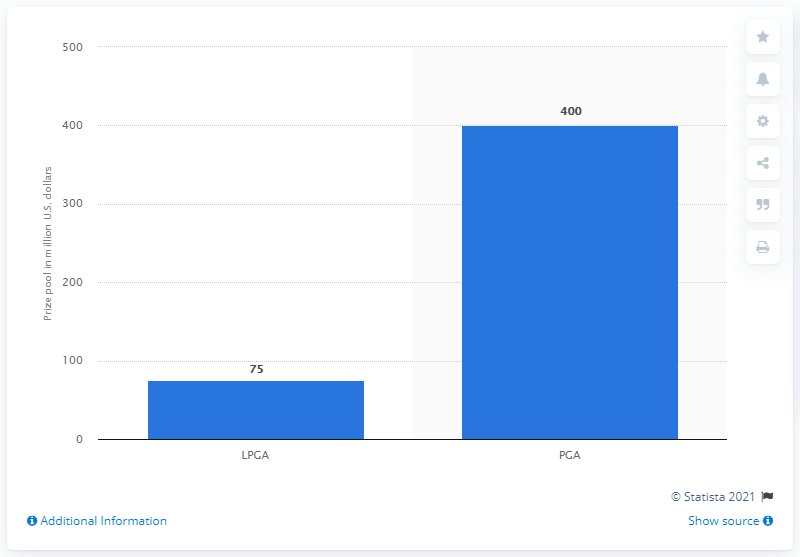Indicate a few pertinent items in this graphic. The total prize pool for the men's PGA Tour in the 2019/2020 season was approximately 400 million dollars. The amount of prize money awarded to women on the LPGA Tour in 2022 was $75 million. 